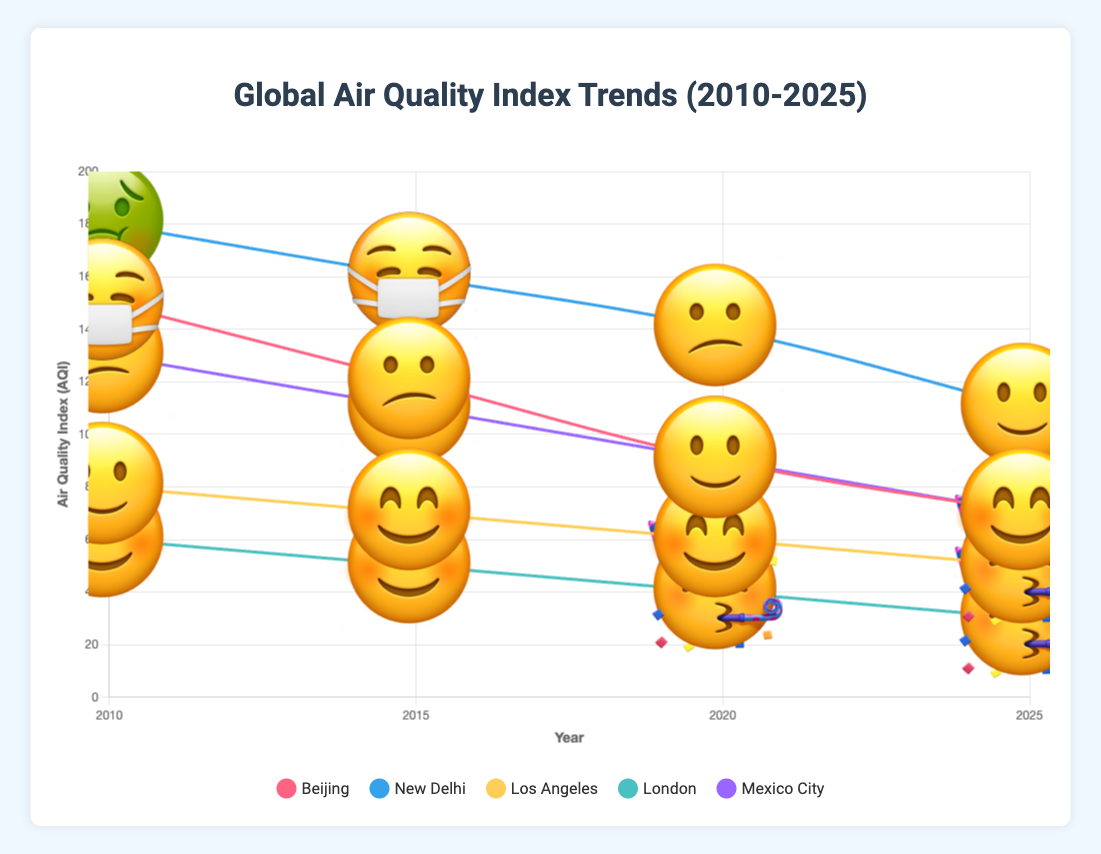What city had the highest AQI value in 2010? In the chart, the AQI values for 2010 are shown for each city. Beijing had an AQI of 150, New Delhi had 180, Los Angeles had 80, London had 60, and Mexico City had 130. New Delhi has the highest value.
Answer: New Delhi How did Beijing's AQI change from 2010 to 2025? Compare Beijing's AQI values from 2010 (150) to 2025 (70). The AQI decreased from 150 to 70.
Answer: Decreased Which city had the best air quality emoji rating in 2025? Look at the emoji ratings for each city in 2025. The ratings are Beijing (😊), New Delhi (🙂), Los Angeles (🥳), London (🥳), and Mexico City (😊). The "🥳" emoji ranks best, which is for Los Angeles and London.
Answer: Los Angeles and London Compare the AQI of Mexico City and Los Angeles in 2020. Which was lower? The AQI for Mexico City in 2020 was 90, and for Los Angeles, it was 60. Therefore, Los Angeles had a lower AQI.
Answer: Los Angeles What was the overall AQI trend for New Delhi between 2010 and 2025? The AQI values for New Delhi from 2010 to 2025 are 180, 160, 140, and 110 respectively. The trend is a gradual decrease in AQI over these years.
Answer: Decreasing Which year did London achieve the "Good" AQI category according to the AQI scale? According to the AQI scale, "Good" category is from 0-50. London had AQI values of 60, 50, 40, and 30 from 2010 to 2025. London achieved the "Good" category in 2020 and 2025.
Answer: 2020 and 2025 Calculate the average AQI for New Delhi across all years shown. Adding New Delhi's AQI values (180, 160, 140, 110) gives a total of 590. Dividing this sum by the number of years (4) gives 147.5 as the average AQI.
Answer: 147.5 Which city showed the greatest improvement in AQI from 2010 to 2025? Compare the AQI decrease from 2010 to 2025 for each city. The decreases are: Beijing (150 to 70, improvement of 80), New Delhi (180 to 110, improvement of 70), Los Angeles (80 to 50, improvement of 30), London (60 to 30, improvement of 30), Mexico City (130 to 70, improvement of 60). Beijing showed the greatest improvement.
Answer: Beijing What is the emoji rating for Los Angeles in 2025? The chart shows the emoji ratings for each year. For Los Angeles in 2025, the emoji rating is "🥳".
Answer: 🥳 